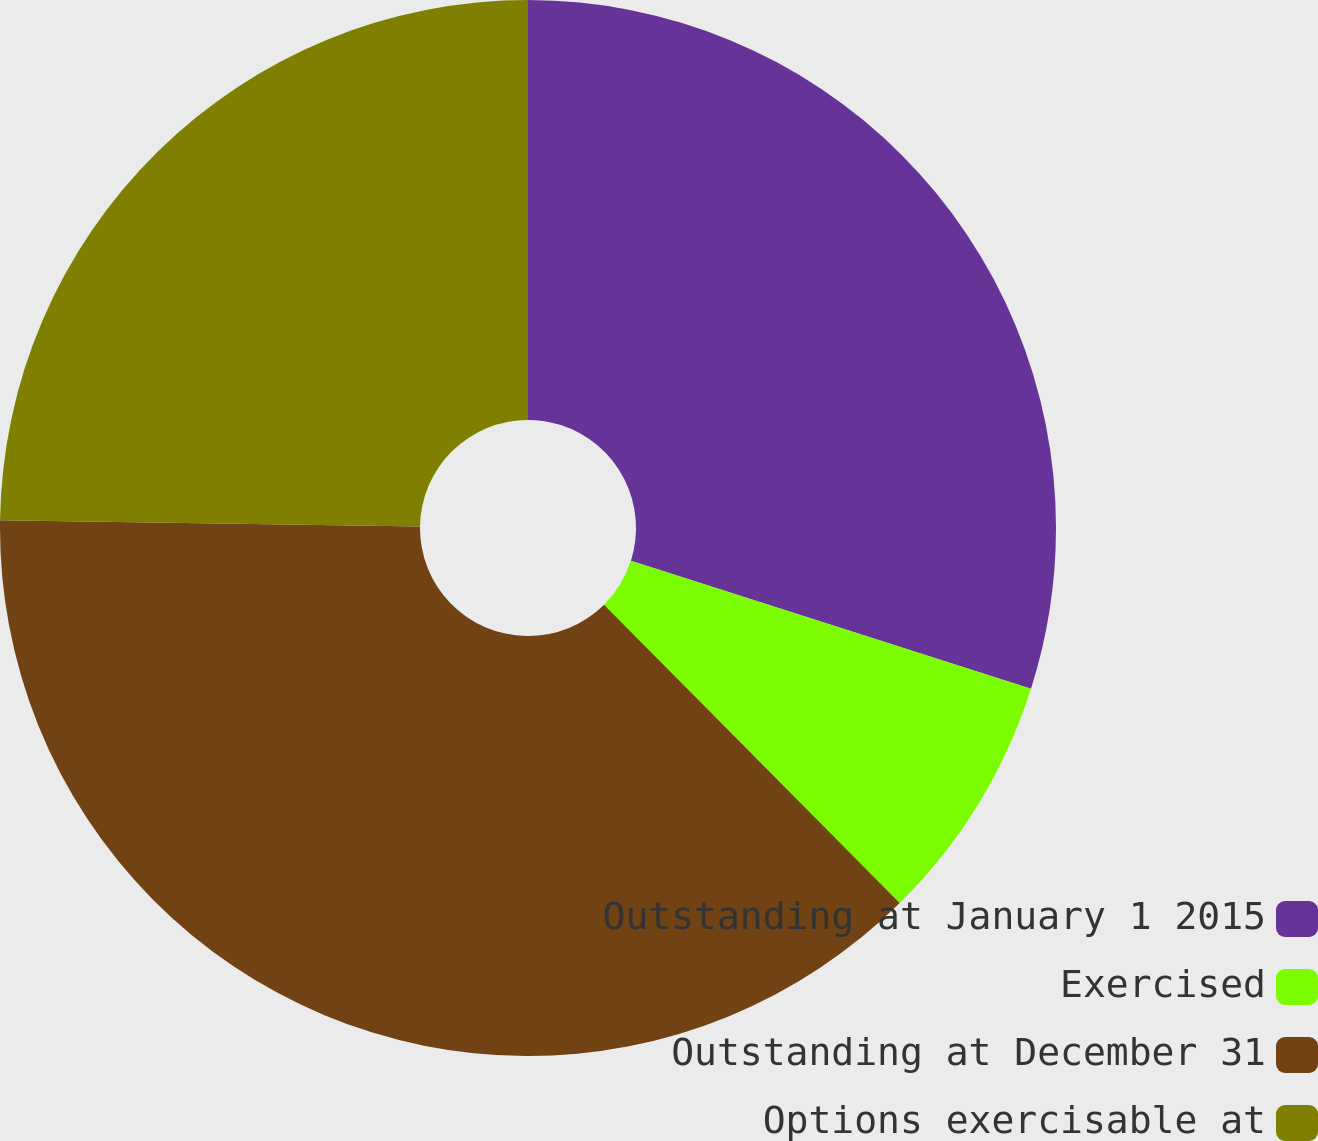Convert chart. <chart><loc_0><loc_0><loc_500><loc_500><pie_chart><fcel>Outstanding at January 1 2015<fcel>Exercised<fcel>Outstanding at December 31<fcel>Options exercisable at<nl><fcel>29.92%<fcel>7.65%<fcel>37.66%<fcel>24.77%<nl></chart> 